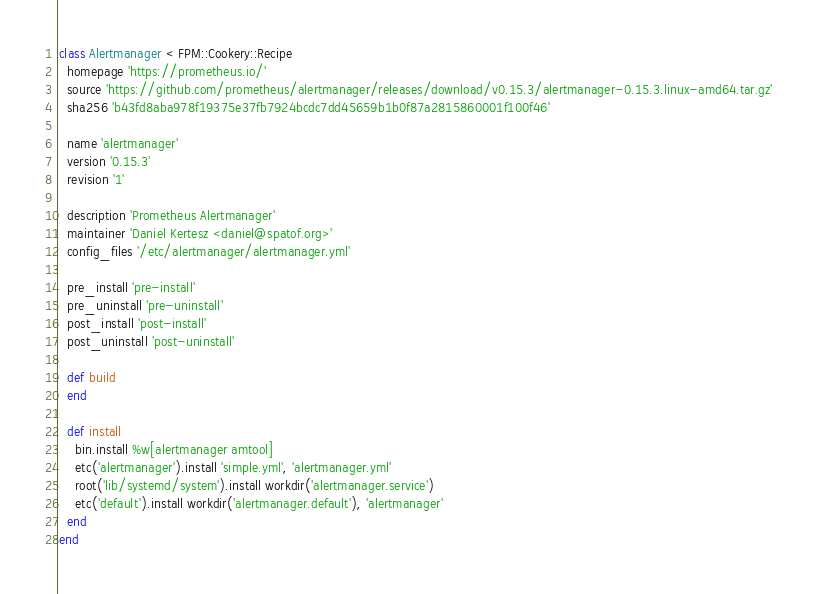Convert code to text. <code><loc_0><loc_0><loc_500><loc_500><_Ruby_>class Alertmanager < FPM::Cookery::Recipe
  homepage 'https://prometheus.io/'
  source 'https://github.com/prometheus/alertmanager/releases/download/v0.15.3/alertmanager-0.15.3.linux-amd64.tar.gz'
  sha256 'b43fd8aba978f19375e37fb7924bcdc7dd45659b1b0f87a2815860001f100f46'

  name 'alertmanager'
  version '0.15.3'
  revision '1'

  description 'Prometheus Alertmanager'
  maintainer 'Daniel Kertesz <daniel@spatof.org>'
  config_files '/etc/alertmanager/alertmanager.yml'

  pre_install 'pre-install'
  pre_uninstall 'pre-uninstall'
  post_install 'post-install'
  post_uninstall 'post-uninstall'

  def build
  end

  def install
    bin.install %w[alertmanager amtool]
    etc('alertmanager').install 'simple.yml', 'alertmanager.yml'
    root('lib/systemd/system').install workdir('alertmanager.service')
    etc('default').install workdir('alertmanager.default'), 'alertmanager'
  end
end
</code> 